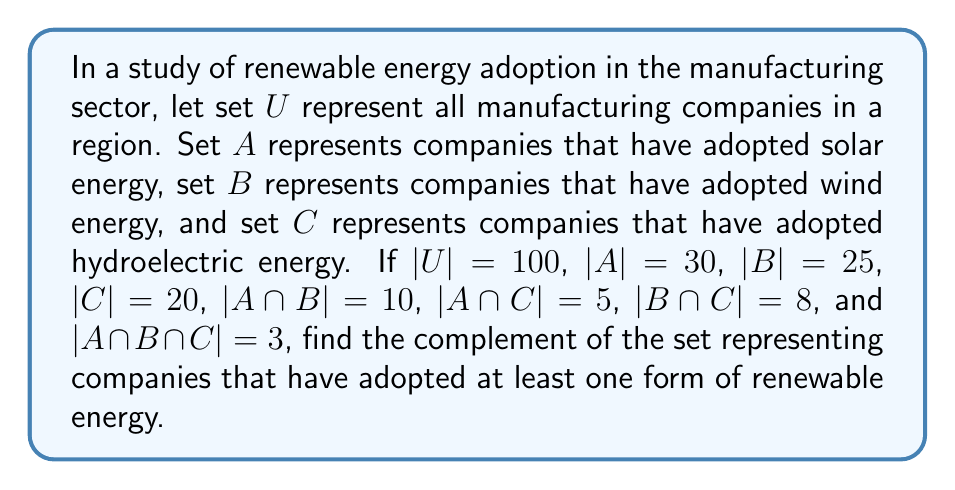Give your solution to this math problem. To solve this problem, we'll follow these steps:

1) First, we need to find the number of companies that have adopted at least one form of renewable energy. Let's call this set $R$ (for Renewable).

2) We can use the inclusion-exclusion principle to find $|R|$:

   $$|R| = |A \cup B \cup C| = |A| + |B| + |C| - |A \cap B| - |A \cap C| - |B \cap C| + |A \cap B \cap C|$$

3) Substituting the given values:

   $$|R| = 30 + 25 + 20 - 10 - 5 - 8 + 3 = 55$$

4) The complement of $R$, let's call it $R^c$, represents companies that have not adopted any form of renewable energy.

5) To find $|R^c|$, we subtract $|R|$ from the total number of companies:

   $$|R^c| = |U| - |R| = 100 - 55 = 45$$

Therefore, 45 companies have not adopted any form of renewable energy.
Answer: The complement of the set representing companies that have adopted at least one form of renewable energy contains 45 companies. 